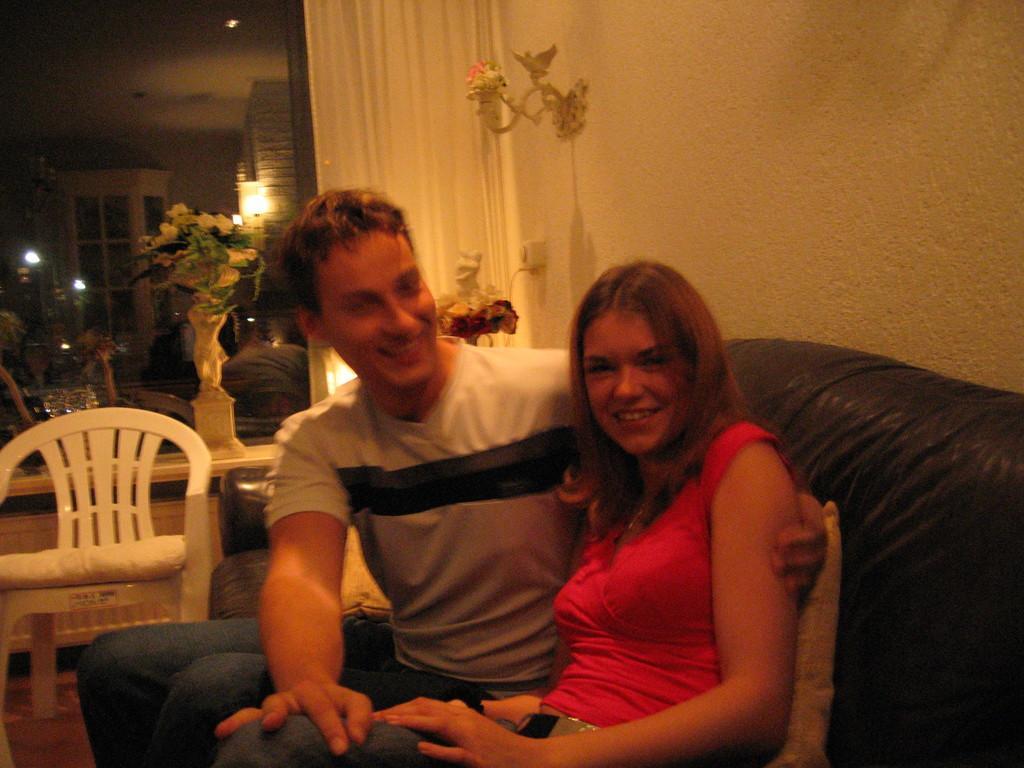Could you give a brief overview of what you see in this image? The picture is taken in a room. In foreground of the picture there is a man and a woman sitting on a couch and there are pillows on the couch. On the left there is a chair. In the background there are lights, flowers, chair, glasses, window, curtain and a mirror. 